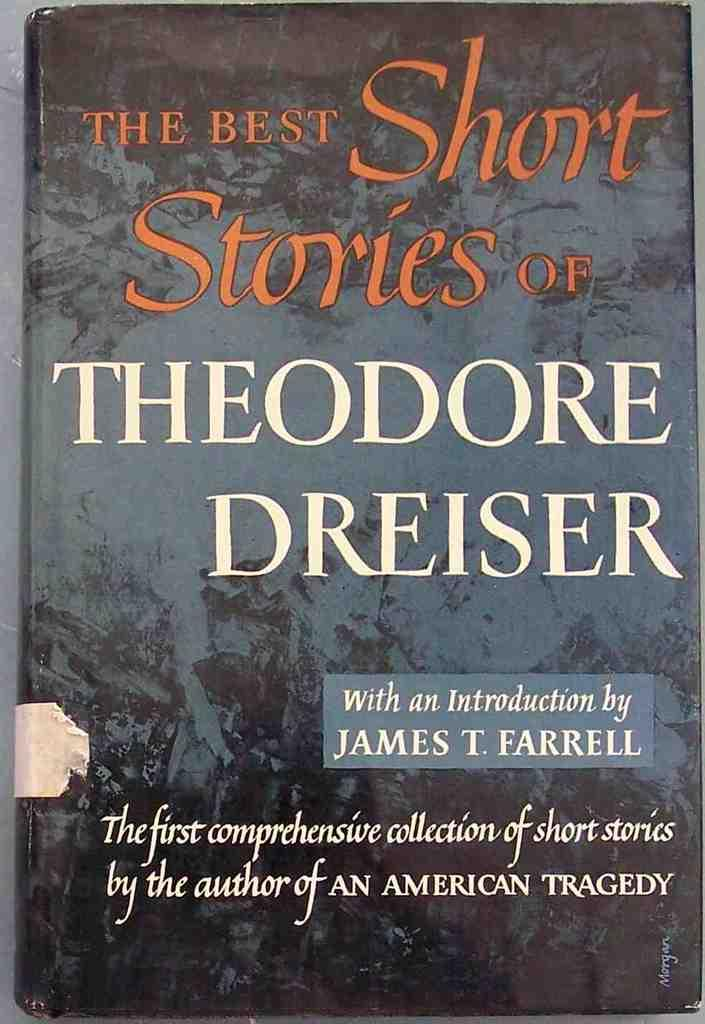<image>
Present a compact description of the photo's key features. A book cover titled The best short stories of Theodore Dreiser. 